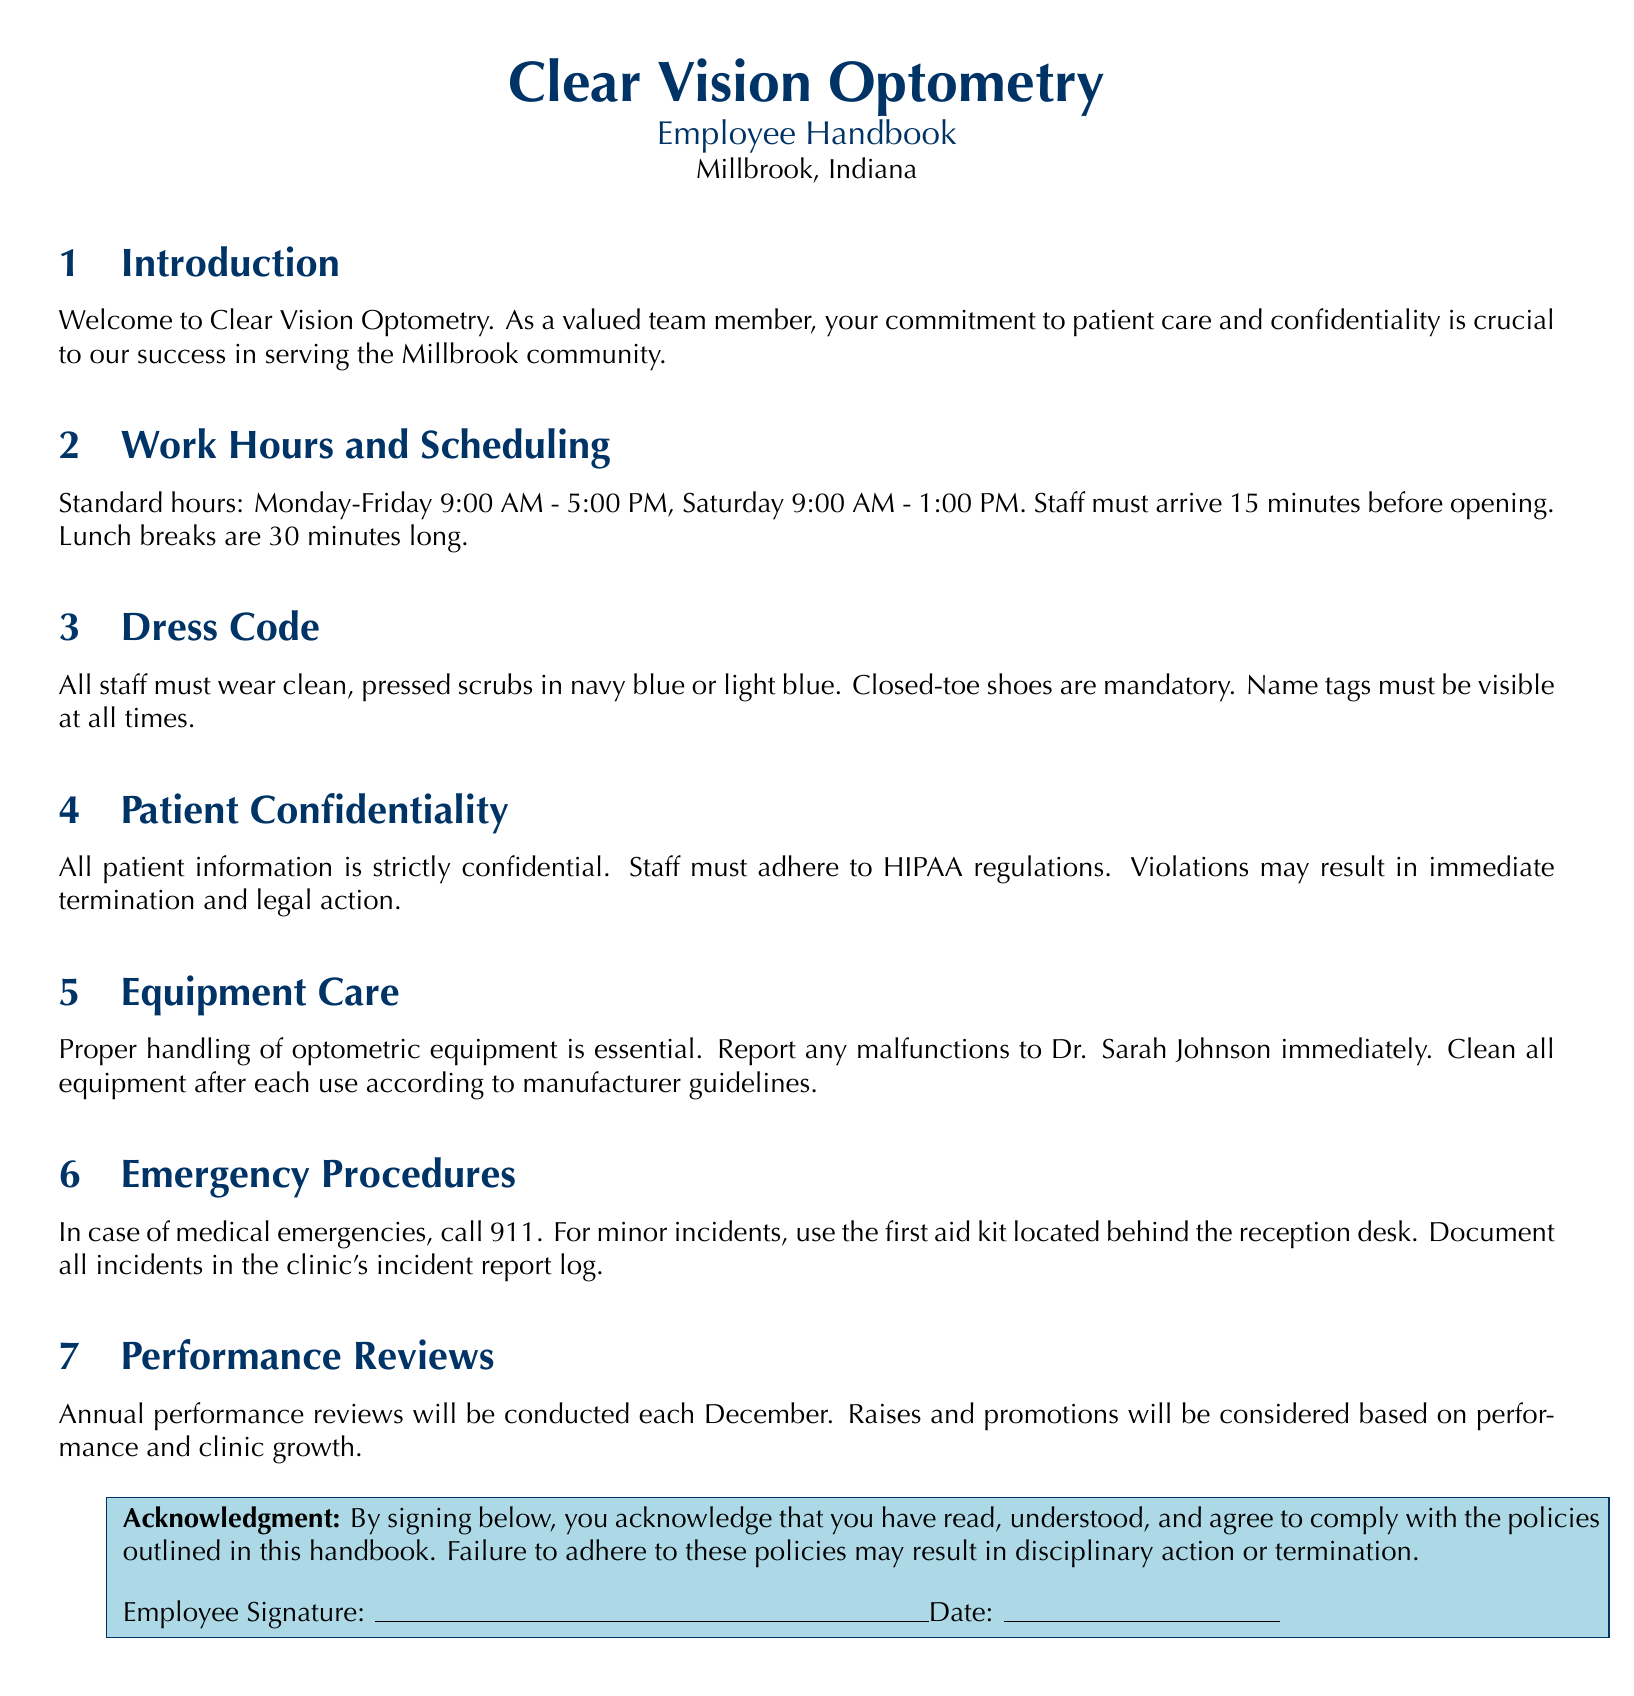What are the clinic's standard hours? The standard hours listed in the document are Monday-Friday 9:00 AM - 5:00 PM, Saturday 9:00 AM - 1:00 PM.
Answer: Monday-Friday 9:00 AM - 5:00 PM, Saturday 9:00 AM - 1:00 PM What must staff wear? The document states that all staff must wear clean, pressed scrubs in navy blue or light blue, along with closed-toe shoes.
Answer: Clean, pressed scrubs in navy blue or light blue, closed-toe shoes What action can lead to immediate termination? The document indicates that violations of patient confidentiality, specifically not adhering to HIPAA regulations, may result in immediate termination.
Answer: Violations of patient confidentiality Who should be notified of equipment malfunctions? The document specifies that any malfunctions of optometric equipment should be reported to Dr. Sarah Johnson.
Answer: Dr. Sarah Johnson What is the duration of lunch breaks? According to the document, staff are entitled to a 30-minute lunch break.
Answer: 30 minutes When will annual performance reviews take place? The annual performance reviews are conducted each December, as mentioned in the document.
Answer: Each December What must staff sign to acknowledge the handbook? Staff are required to sign an acknowledgment in the document confirming they have read and understood the policies outlined.
Answer: Acknowledgment of reading and understanding policies What must be documented in the incident report log? The document dictates that all incidents, particularly minor ones after first aid response, must be documented in the clinic's incident report log.
Answer: All incidents What is the first step in case of a medical emergency? The policy states that the first step in case of medical emergencies is to call 911.
Answer: Call 911 